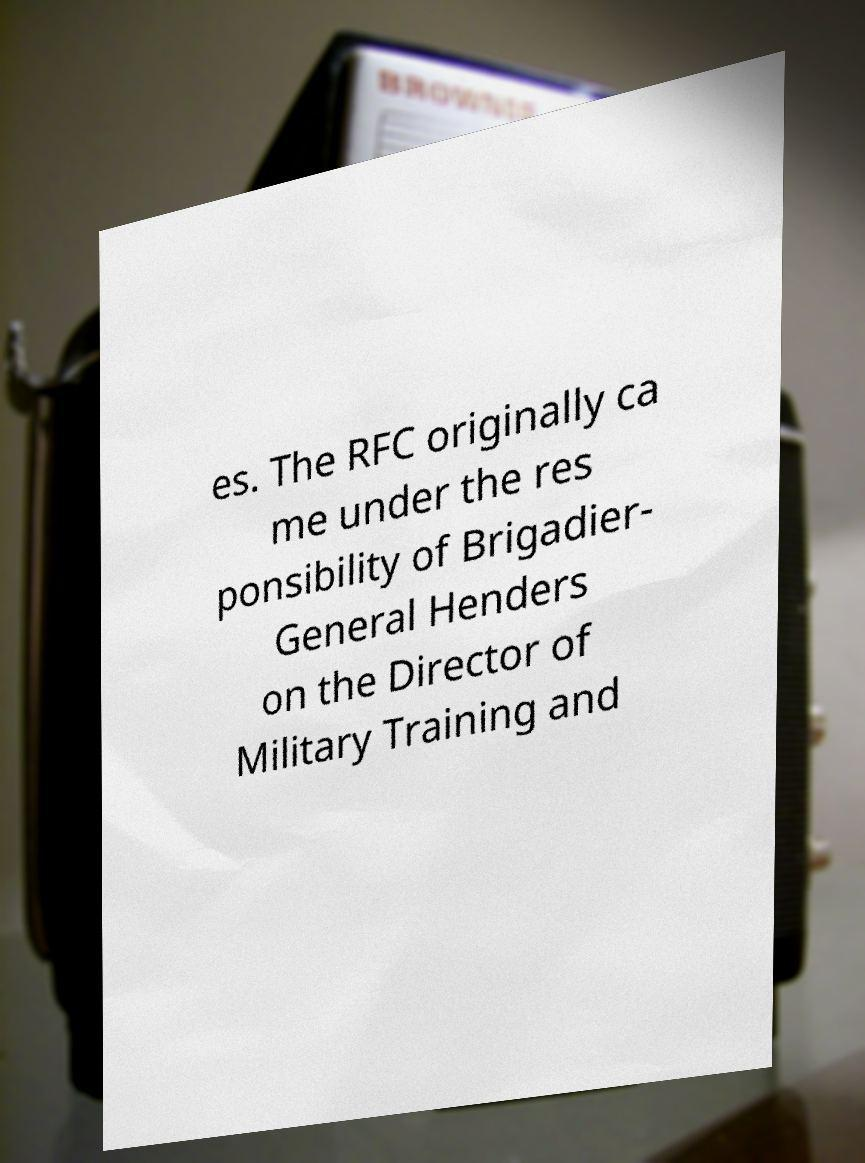I need the written content from this picture converted into text. Can you do that? es. The RFC originally ca me under the res ponsibility of Brigadier- General Henders on the Director of Military Training and 